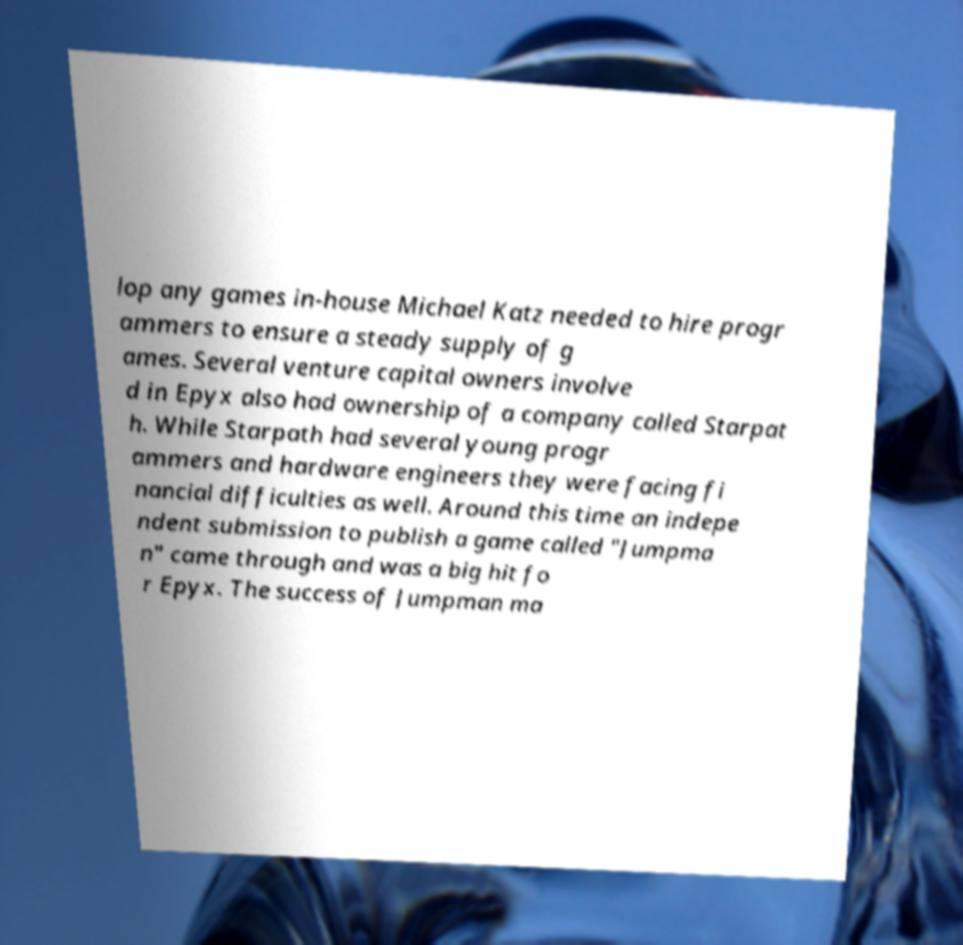What messages or text are displayed in this image? I need them in a readable, typed format. lop any games in-house Michael Katz needed to hire progr ammers to ensure a steady supply of g ames. Several venture capital owners involve d in Epyx also had ownership of a company called Starpat h. While Starpath had several young progr ammers and hardware engineers they were facing fi nancial difficulties as well. Around this time an indepe ndent submission to publish a game called "Jumpma n" came through and was a big hit fo r Epyx. The success of Jumpman ma 